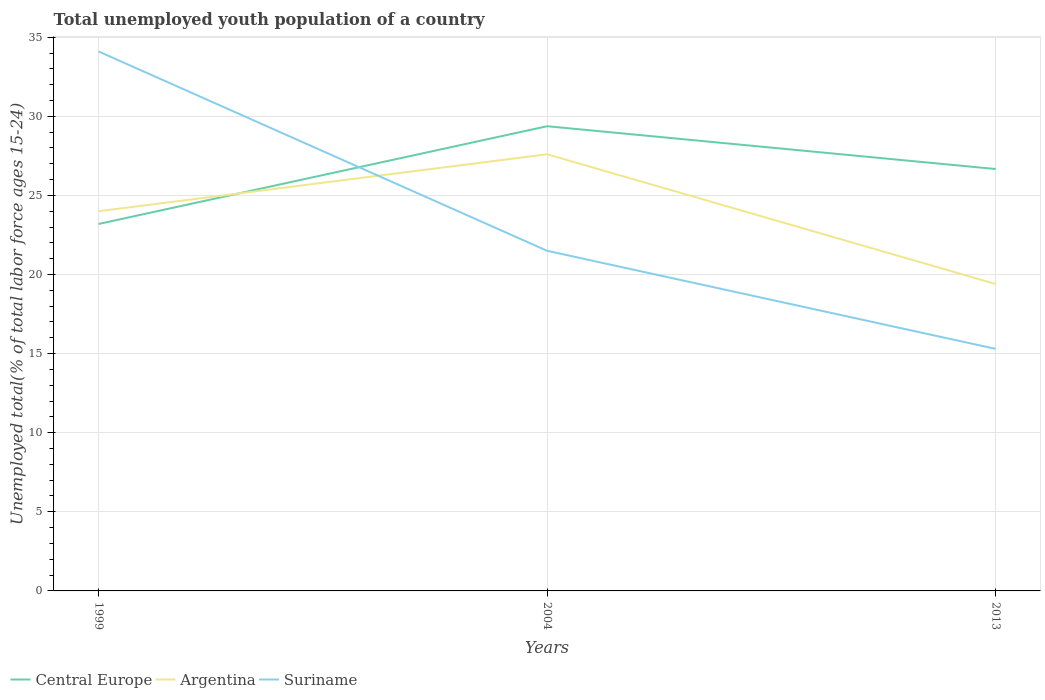Is the number of lines equal to the number of legend labels?
Your answer should be very brief. Yes. Across all years, what is the maximum percentage of total unemployed youth population of a country in Suriname?
Make the answer very short. 15.3. In which year was the percentage of total unemployed youth population of a country in Argentina maximum?
Provide a short and direct response. 2013. What is the total percentage of total unemployed youth population of a country in Argentina in the graph?
Offer a terse response. -3.6. What is the difference between the highest and the second highest percentage of total unemployed youth population of a country in Suriname?
Provide a succinct answer. 18.8. What is the difference between the highest and the lowest percentage of total unemployed youth population of a country in Central Europe?
Your response must be concise. 2. Is the percentage of total unemployed youth population of a country in Suriname strictly greater than the percentage of total unemployed youth population of a country in Argentina over the years?
Give a very brief answer. No. What is the difference between two consecutive major ticks on the Y-axis?
Offer a terse response. 5. Are the values on the major ticks of Y-axis written in scientific E-notation?
Provide a succinct answer. No. Does the graph contain any zero values?
Offer a terse response. No. What is the title of the graph?
Keep it short and to the point. Total unemployed youth population of a country. Does "Serbia" appear as one of the legend labels in the graph?
Offer a terse response. No. What is the label or title of the Y-axis?
Your response must be concise. Unemployed total(% of total labor force ages 15-24). What is the Unemployed total(% of total labor force ages 15-24) of Central Europe in 1999?
Provide a succinct answer. 23.19. What is the Unemployed total(% of total labor force ages 15-24) in Argentina in 1999?
Your answer should be very brief. 24. What is the Unemployed total(% of total labor force ages 15-24) in Suriname in 1999?
Give a very brief answer. 34.1. What is the Unemployed total(% of total labor force ages 15-24) of Central Europe in 2004?
Make the answer very short. 29.37. What is the Unemployed total(% of total labor force ages 15-24) in Argentina in 2004?
Ensure brevity in your answer.  27.6. What is the Unemployed total(% of total labor force ages 15-24) of Suriname in 2004?
Ensure brevity in your answer.  21.5. What is the Unemployed total(% of total labor force ages 15-24) of Central Europe in 2013?
Provide a short and direct response. 26.67. What is the Unemployed total(% of total labor force ages 15-24) in Argentina in 2013?
Offer a very short reply. 19.4. What is the Unemployed total(% of total labor force ages 15-24) in Suriname in 2013?
Offer a very short reply. 15.3. Across all years, what is the maximum Unemployed total(% of total labor force ages 15-24) in Central Europe?
Your answer should be very brief. 29.37. Across all years, what is the maximum Unemployed total(% of total labor force ages 15-24) of Argentina?
Your answer should be compact. 27.6. Across all years, what is the maximum Unemployed total(% of total labor force ages 15-24) of Suriname?
Your response must be concise. 34.1. Across all years, what is the minimum Unemployed total(% of total labor force ages 15-24) of Central Europe?
Offer a very short reply. 23.19. Across all years, what is the minimum Unemployed total(% of total labor force ages 15-24) of Argentina?
Provide a succinct answer. 19.4. Across all years, what is the minimum Unemployed total(% of total labor force ages 15-24) in Suriname?
Your answer should be compact. 15.3. What is the total Unemployed total(% of total labor force ages 15-24) in Central Europe in the graph?
Offer a very short reply. 79.24. What is the total Unemployed total(% of total labor force ages 15-24) in Argentina in the graph?
Your answer should be compact. 71. What is the total Unemployed total(% of total labor force ages 15-24) in Suriname in the graph?
Provide a succinct answer. 70.9. What is the difference between the Unemployed total(% of total labor force ages 15-24) of Central Europe in 1999 and that in 2004?
Keep it short and to the point. -6.18. What is the difference between the Unemployed total(% of total labor force ages 15-24) in Argentina in 1999 and that in 2004?
Your answer should be compact. -3.6. What is the difference between the Unemployed total(% of total labor force ages 15-24) of Suriname in 1999 and that in 2004?
Make the answer very short. 12.6. What is the difference between the Unemployed total(% of total labor force ages 15-24) in Central Europe in 1999 and that in 2013?
Offer a terse response. -3.47. What is the difference between the Unemployed total(% of total labor force ages 15-24) of Argentina in 1999 and that in 2013?
Your answer should be very brief. 4.6. What is the difference between the Unemployed total(% of total labor force ages 15-24) of Central Europe in 2004 and that in 2013?
Offer a very short reply. 2.71. What is the difference between the Unemployed total(% of total labor force ages 15-24) in Argentina in 2004 and that in 2013?
Your answer should be compact. 8.2. What is the difference between the Unemployed total(% of total labor force ages 15-24) in Suriname in 2004 and that in 2013?
Give a very brief answer. 6.2. What is the difference between the Unemployed total(% of total labor force ages 15-24) of Central Europe in 1999 and the Unemployed total(% of total labor force ages 15-24) of Argentina in 2004?
Keep it short and to the point. -4.41. What is the difference between the Unemployed total(% of total labor force ages 15-24) in Central Europe in 1999 and the Unemployed total(% of total labor force ages 15-24) in Suriname in 2004?
Your response must be concise. 1.69. What is the difference between the Unemployed total(% of total labor force ages 15-24) in Argentina in 1999 and the Unemployed total(% of total labor force ages 15-24) in Suriname in 2004?
Keep it short and to the point. 2.5. What is the difference between the Unemployed total(% of total labor force ages 15-24) in Central Europe in 1999 and the Unemployed total(% of total labor force ages 15-24) in Argentina in 2013?
Your answer should be very brief. 3.79. What is the difference between the Unemployed total(% of total labor force ages 15-24) of Central Europe in 1999 and the Unemployed total(% of total labor force ages 15-24) of Suriname in 2013?
Your answer should be very brief. 7.89. What is the difference between the Unemployed total(% of total labor force ages 15-24) of Argentina in 1999 and the Unemployed total(% of total labor force ages 15-24) of Suriname in 2013?
Offer a terse response. 8.7. What is the difference between the Unemployed total(% of total labor force ages 15-24) in Central Europe in 2004 and the Unemployed total(% of total labor force ages 15-24) in Argentina in 2013?
Your answer should be very brief. 9.97. What is the difference between the Unemployed total(% of total labor force ages 15-24) of Central Europe in 2004 and the Unemployed total(% of total labor force ages 15-24) of Suriname in 2013?
Your response must be concise. 14.07. What is the average Unemployed total(% of total labor force ages 15-24) of Central Europe per year?
Offer a very short reply. 26.41. What is the average Unemployed total(% of total labor force ages 15-24) of Argentina per year?
Provide a succinct answer. 23.67. What is the average Unemployed total(% of total labor force ages 15-24) in Suriname per year?
Provide a succinct answer. 23.63. In the year 1999, what is the difference between the Unemployed total(% of total labor force ages 15-24) in Central Europe and Unemployed total(% of total labor force ages 15-24) in Argentina?
Ensure brevity in your answer.  -0.81. In the year 1999, what is the difference between the Unemployed total(% of total labor force ages 15-24) of Central Europe and Unemployed total(% of total labor force ages 15-24) of Suriname?
Keep it short and to the point. -10.91. In the year 1999, what is the difference between the Unemployed total(% of total labor force ages 15-24) in Argentina and Unemployed total(% of total labor force ages 15-24) in Suriname?
Your response must be concise. -10.1. In the year 2004, what is the difference between the Unemployed total(% of total labor force ages 15-24) in Central Europe and Unemployed total(% of total labor force ages 15-24) in Argentina?
Your response must be concise. 1.77. In the year 2004, what is the difference between the Unemployed total(% of total labor force ages 15-24) of Central Europe and Unemployed total(% of total labor force ages 15-24) of Suriname?
Provide a succinct answer. 7.87. In the year 2013, what is the difference between the Unemployed total(% of total labor force ages 15-24) of Central Europe and Unemployed total(% of total labor force ages 15-24) of Argentina?
Ensure brevity in your answer.  7.27. In the year 2013, what is the difference between the Unemployed total(% of total labor force ages 15-24) in Central Europe and Unemployed total(% of total labor force ages 15-24) in Suriname?
Offer a terse response. 11.37. In the year 2013, what is the difference between the Unemployed total(% of total labor force ages 15-24) in Argentina and Unemployed total(% of total labor force ages 15-24) in Suriname?
Keep it short and to the point. 4.1. What is the ratio of the Unemployed total(% of total labor force ages 15-24) in Central Europe in 1999 to that in 2004?
Provide a short and direct response. 0.79. What is the ratio of the Unemployed total(% of total labor force ages 15-24) in Argentina in 1999 to that in 2004?
Provide a short and direct response. 0.87. What is the ratio of the Unemployed total(% of total labor force ages 15-24) in Suriname in 1999 to that in 2004?
Your answer should be very brief. 1.59. What is the ratio of the Unemployed total(% of total labor force ages 15-24) in Central Europe in 1999 to that in 2013?
Give a very brief answer. 0.87. What is the ratio of the Unemployed total(% of total labor force ages 15-24) in Argentina in 1999 to that in 2013?
Give a very brief answer. 1.24. What is the ratio of the Unemployed total(% of total labor force ages 15-24) in Suriname in 1999 to that in 2013?
Make the answer very short. 2.23. What is the ratio of the Unemployed total(% of total labor force ages 15-24) in Central Europe in 2004 to that in 2013?
Provide a succinct answer. 1.1. What is the ratio of the Unemployed total(% of total labor force ages 15-24) in Argentina in 2004 to that in 2013?
Make the answer very short. 1.42. What is the ratio of the Unemployed total(% of total labor force ages 15-24) in Suriname in 2004 to that in 2013?
Ensure brevity in your answer.  1.41. What is the difference between the highest and the second highest Unemployed total(% of total labor force ages 15-24) of Central Europe?
Keep it short and to the point. 2.71. What is the difference between the highest and the lowest Unemployed total(% of total labor force ages 15-24) of Central Europe?
Your answer should be compact. 6.18. 